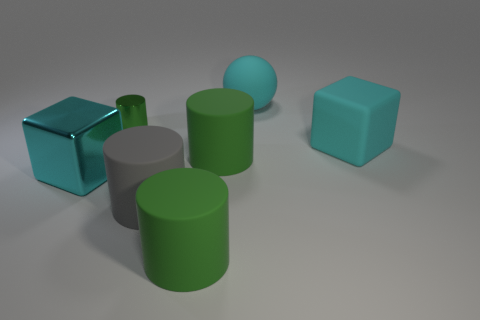Subtract all green cylinders. How many were subtracted if there are2green cylinders left? 1 Subtract all big rubber cylinders. How many cylinders are left? 1 Subtract all yellow balls. How many green cylinders are left? 3 Subtract all gray cylinders. How many cylinders are left? 3 Add 1 big metallic blocks. How many objects exist? 8 Subtract 1 cylinders. How many cylinders are left? 3 Subtract all small green cylinders. Subtract all big cyan shiny blocks. How many objects are left? 5 Add 3 small things. How many small things are left? 4 Add 5 yellow balls. How many yellow balls exist? 5 Subtract 0 purple cylinders. How many objects are left? 7 